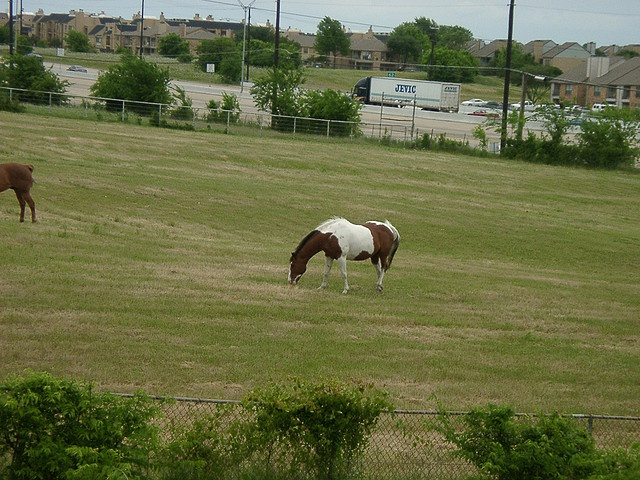Describe the objects in this image and their specific colors. I can see horse in lightblue, black, darkgray, gray, and lightgray tones, truck in lightblue, darkgray, black, and gray tones, horse in lightblue, black, maroon, and olive tones, truck in lightblue, darkgray, gray, ivory, and darkgreen tones, and car in lightblue, darkgray, darkgreen, gray, and maroon tones in this image. 